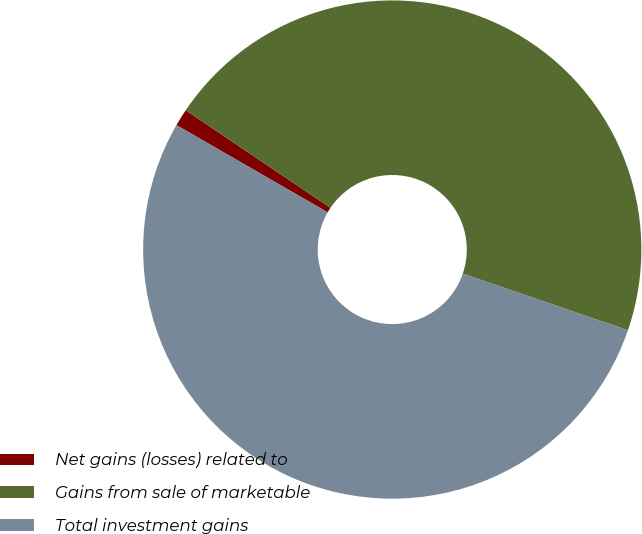Convert chart to OTSL. <chart><loc_0><loc_0><loc_500><loc_500><pie_chart><fcel>Net gains (losses) related to<fcel>Gains from sale of marketable<fcel>Total investment gains<nl><fcel>1.12%<fcel>45.81%<fcel>53.07%<nl></chart> 